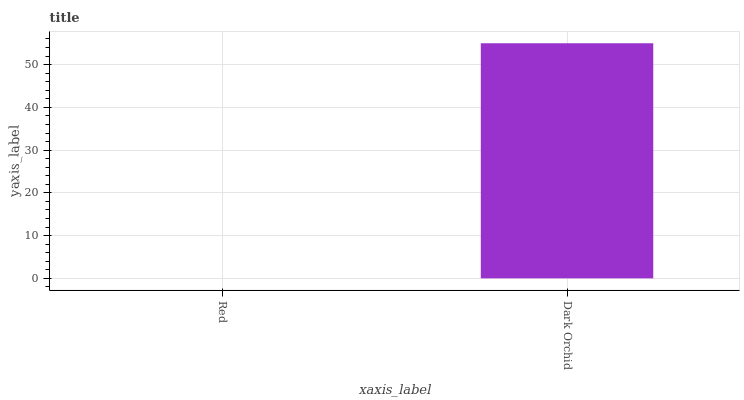Is Dark Orchid the minimum?
Answer yes or no. No. Is Dark Orchid greater than Red?
Answer yes or no. Yes. Is Red less than Dark Orchid?
Answer yes or no. Yes. Is Red greater than Dark Orchid?
Answer yes or no. No. Is Dark Orchid less than Red?
Answer yes or no. No. Is Dark Orchid the high median?
Answer yes or no. Yes. Is Red the low median?
Answer yes or no. Yes. Is Red the high median?
Answer yes or no. No. Is Dark Orchid the low median?
Answer yes or no. No. 